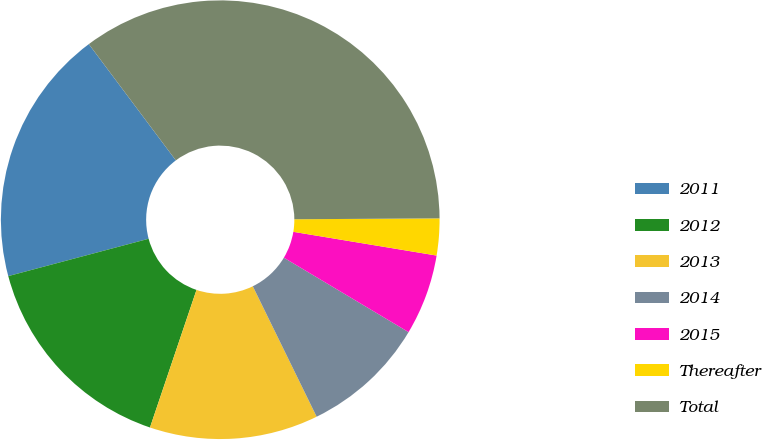<chart> <loc_0><loc_0><loc_500><loc_500><pie_chart><fcel>2011<fcel>2012<fcel>2013<fcel>2014<fcel>2015<fcel>Thereafter<fcel>Total<nl><fcel>18.91%<fcel>15.67%<fcel>12.43%<fcel>9.19%<fcel>5.95%<fcel>2.71%<fcel>35.12%<nl></chart> 